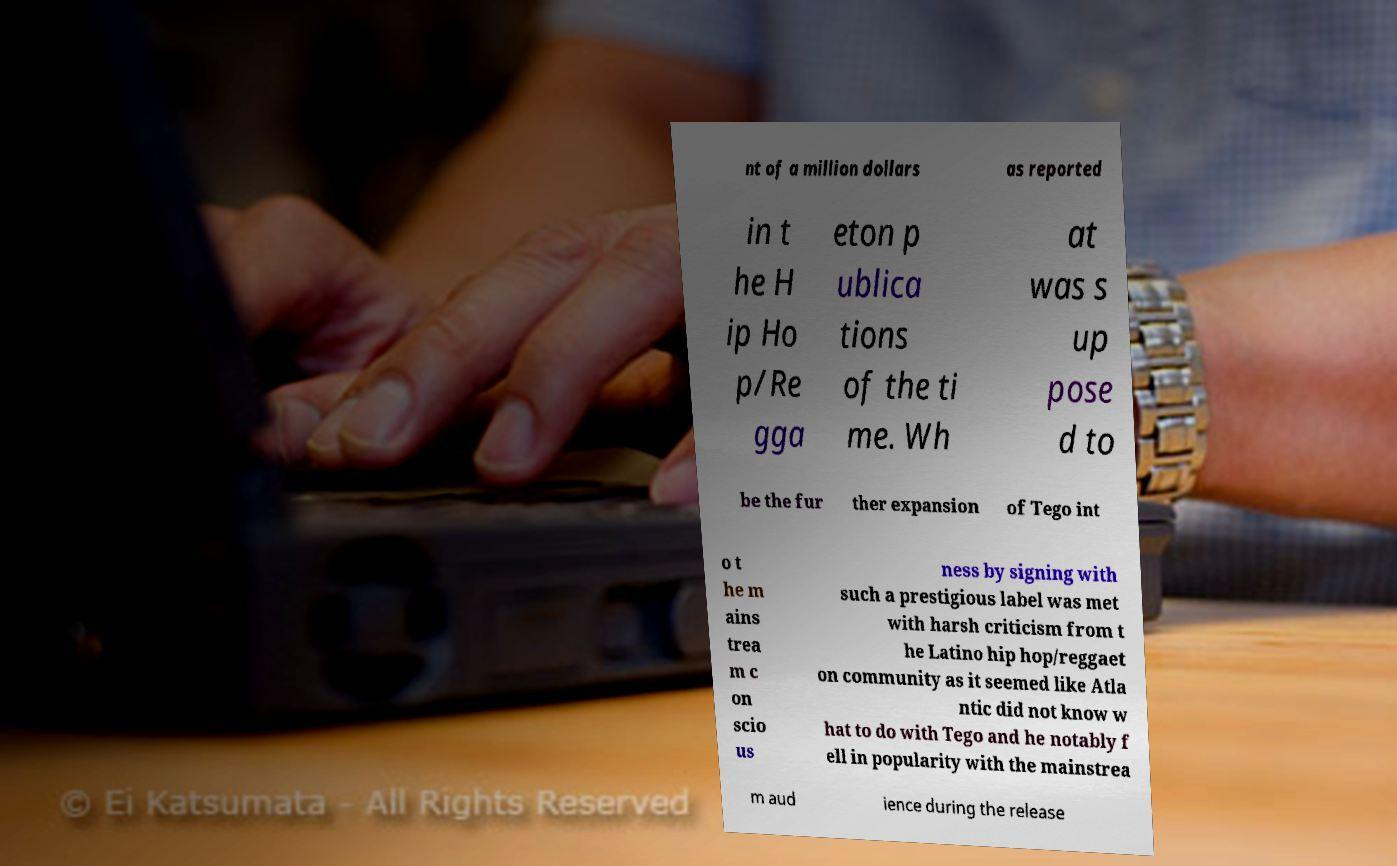I need the written content from this picture converted into text. Can you do that? nt of a million dollars as reported in t he H ip Ho p/Re gga eton p ublica tions of the ti me. Wh at was s up pose d to be the fur ther expansion of Tego int o t he m ains trea m c on scio us ness by signing with such a prestigious label was met with harsh criticism from t he Latino hip hop/reggaet on community as it seemed like Atla ntic did not know w hat to do with Tego and he notably f ell in popularity with the mainstrea m aud ience during the release 